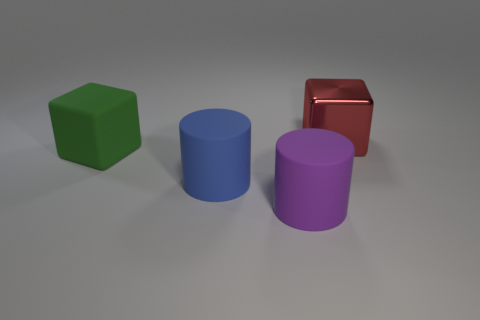Add 2 big yellow things. How many objects exist? 6 Add 1 tiny blue shiny cubes. How many tiny blue shiny cubes exist? 1 Subtract 0 yellow blocks. How many objects are left? 4 Subtract all small yellow things. Subtract all red things. How many objects are left? 3 Add 2 green matte blocks. How many green matte blocks are left? 3 